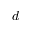<formula> <loc_0><loc_0><loc_500><loc_500>d</formula> 